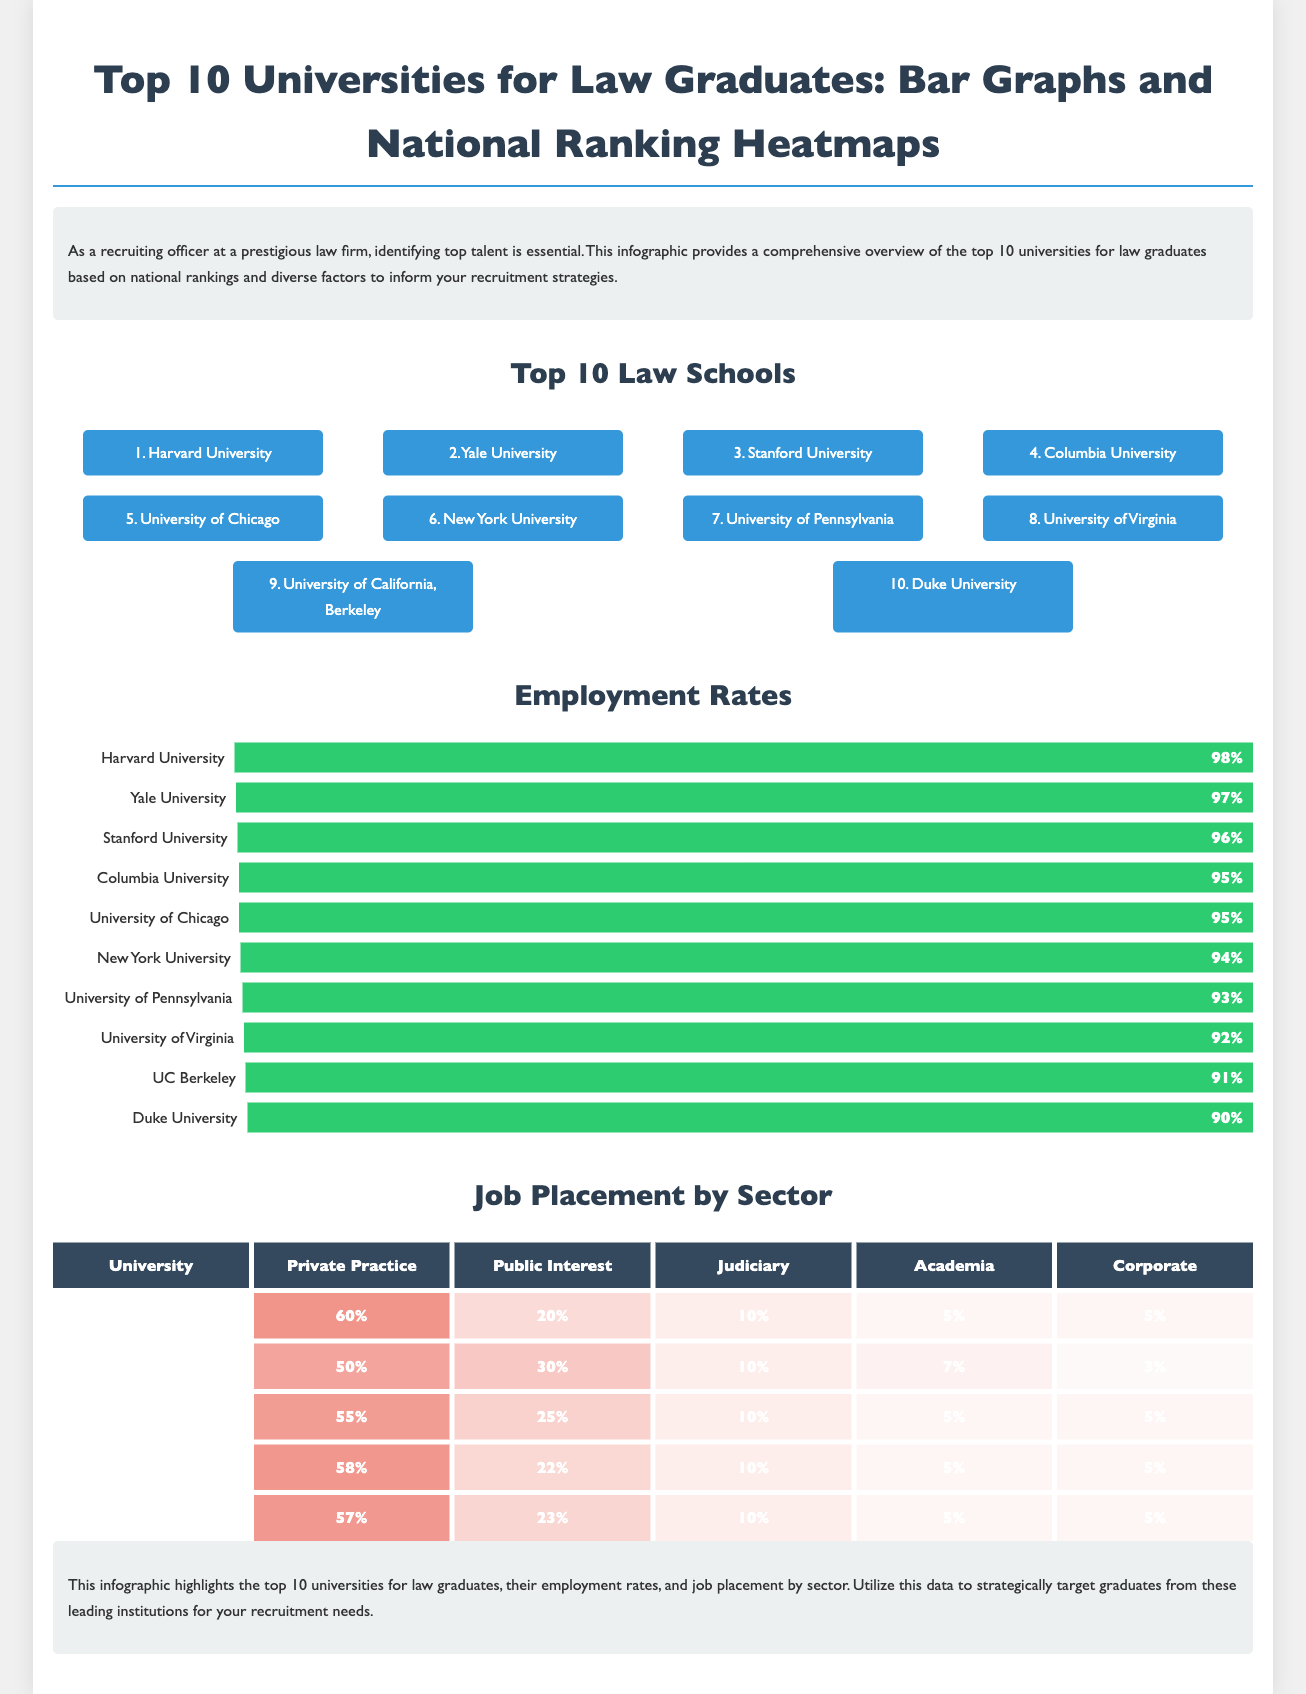What is the top-ranked law school? The document lists Harvard University as the top university in the top 10 law schools section.
Answer: Harvard University What is the employment rate for Yale University? The bar graph indicates that Yale University has an employment rate of 97%.
Answer: 97% Which university has a 95% employment rate? According to the document, both Columbia University and the University of Chicago report a 95% employment rate.
Answer: Columbia University, University of Chicago What percentage of Harvard graduates work in private practice? The heatmap reveals that 60% of Harvard graduates are employed in private practice.
Answer: 60% Which university ranks 5th in the top law schools? The document states that the University of Chicago is ranked 5th amongst the top law schools.
Answer: University of Chicago Which law school has the lowest employment rate among the top 10? The bar graph shows that Duke University has the lowest employment rate at 90%.
Answer: Duke University Which sector employs most of Yale's graduates? The heatmap indicates that 50% of Yale's graduates work in private practice.
Answer: Private Practice How many law schools have an employment rate of 96% or above? The document mentions six law schools with employment rates of 96% or higher, namely Harvard, Yale, Stanford, Columbia, Chicago, and New York University.
Answer: Six What is the color used to represent high percentages in the heatmap? The heatmap uses red shades to represent the various percentages, indicating job placement by sector.
Answer: Red shades 